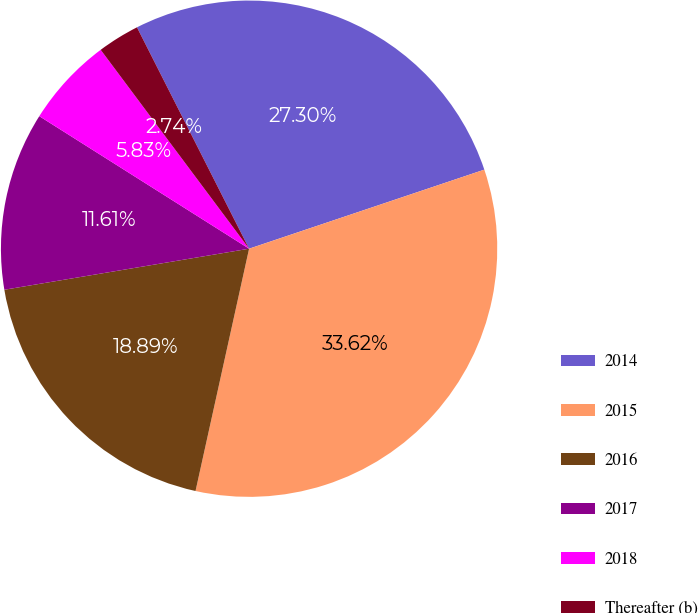<chart> <loc_0><loc_0><loc_500><loc_500><pie_chart><fcel>2014<fcel>2015<fcel>2016<fcel>2017<fcel>2018<fcel>Thereafter (b)<nl><fcel>27.3%<fcel>33.62%<fcel>18.89%<fcel>11.61%<fcel>5.83%<fcel>2.74%<nl></chart> 